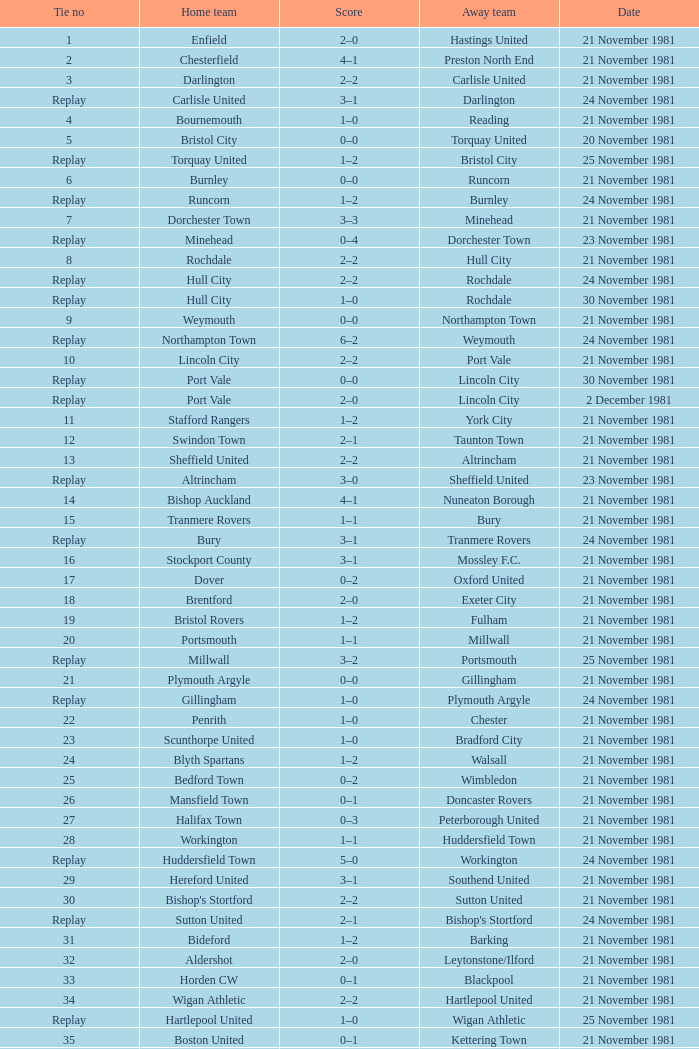Minehead has what tie number? Replay. 